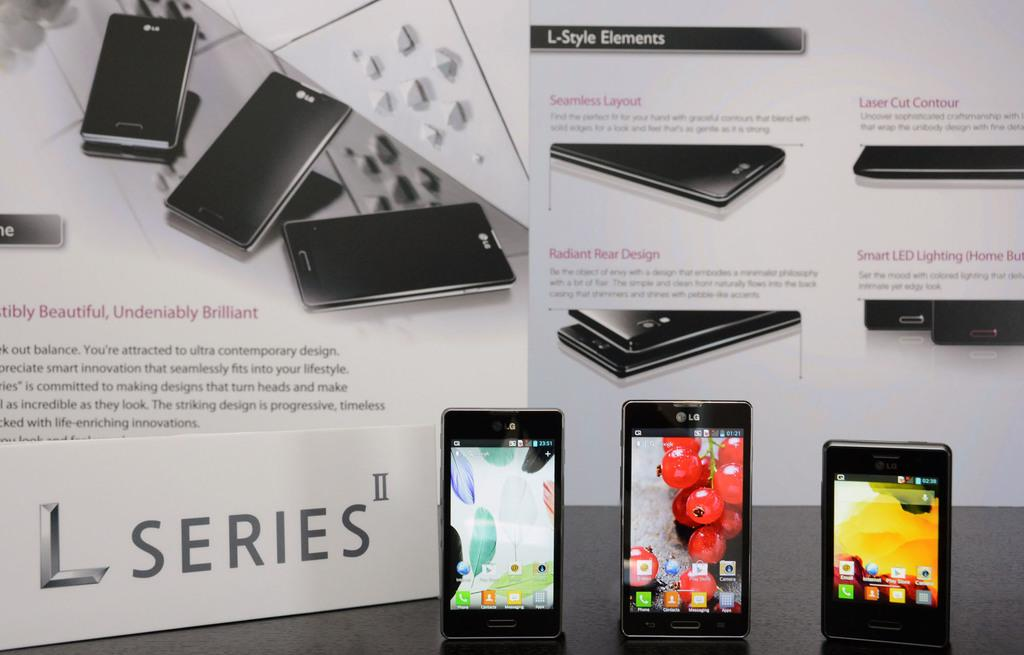<image>
Describe the image concisely. Three black L Series phones standing upright next to an advertisement display board. 